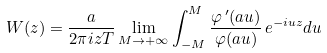Convert formula to latex. <formula><loc_0><loc_0><loc_500><loc_500>W ( z ) = \frac { a } { 2 \pi i z T } \lim _ { M \to + \infty } \int _ { - M } ^ { M } \frac { \varphi \, ^ { \prime } ( a u ) } { \varphi ( a u ) } \, e ^ { - i u z } d u</formula> 